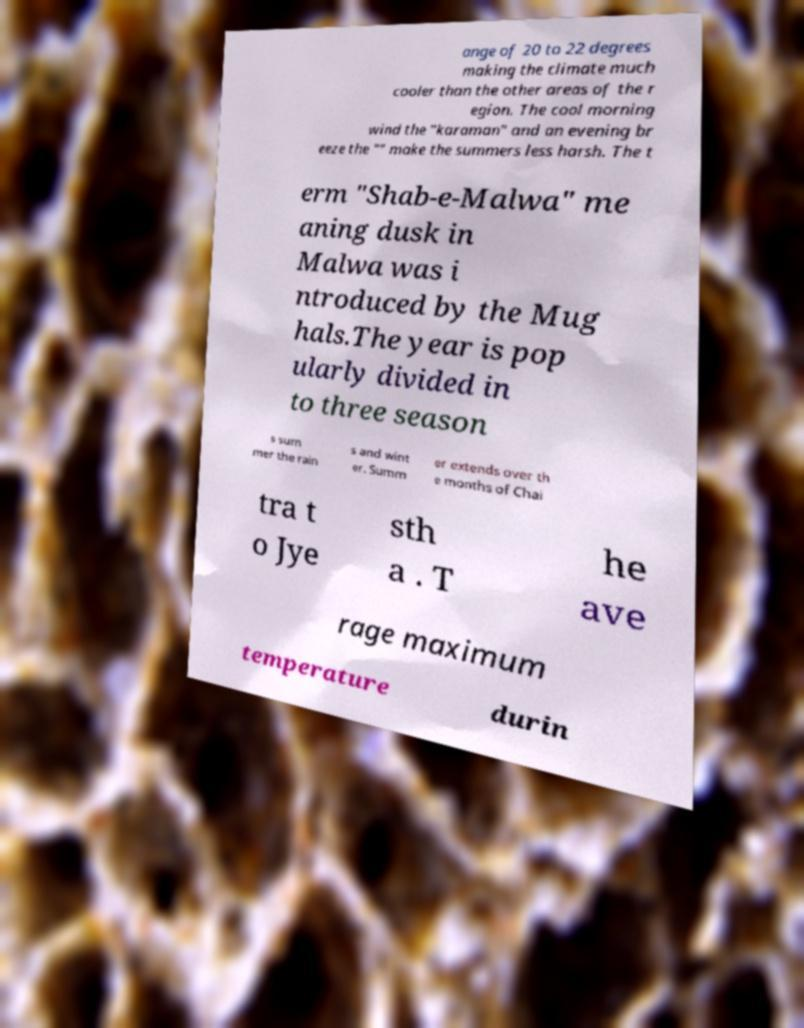What messages or text are displayed in this image? I need them in a readable, typed format. ange of 20 to 22 degrees making the climate much cooler than the other areas of the r egion. The cool morning wind the "karaman" and an evening br eeze the "" make the summers less harsh. The t erm "Shab-e-Malwa" me aning dusk in Malwa was i ntroduced by the Mug hals.The year is pop ularly divided in to three season s sum mer the rain s and wint er. Summ er extends over th e months of Chai tra t o Jye sth a . T he ave rage maximum temperature durin 